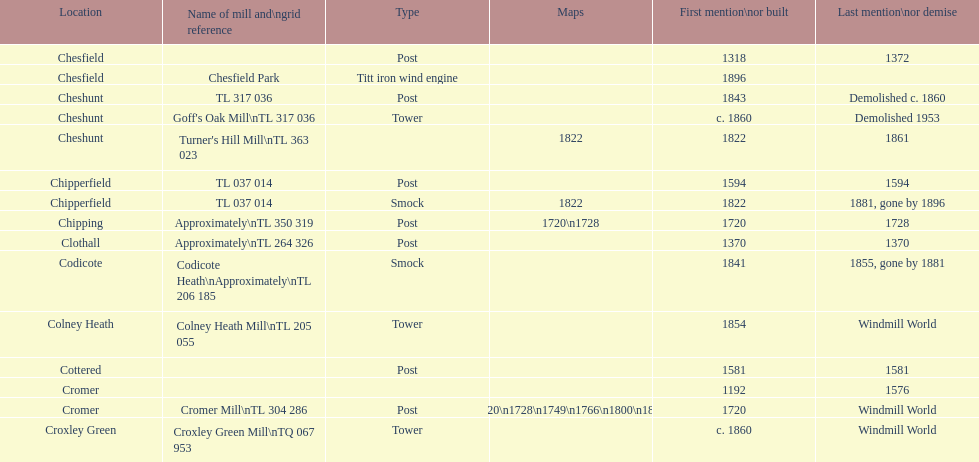What is the number of locations without any photographs? 14. 